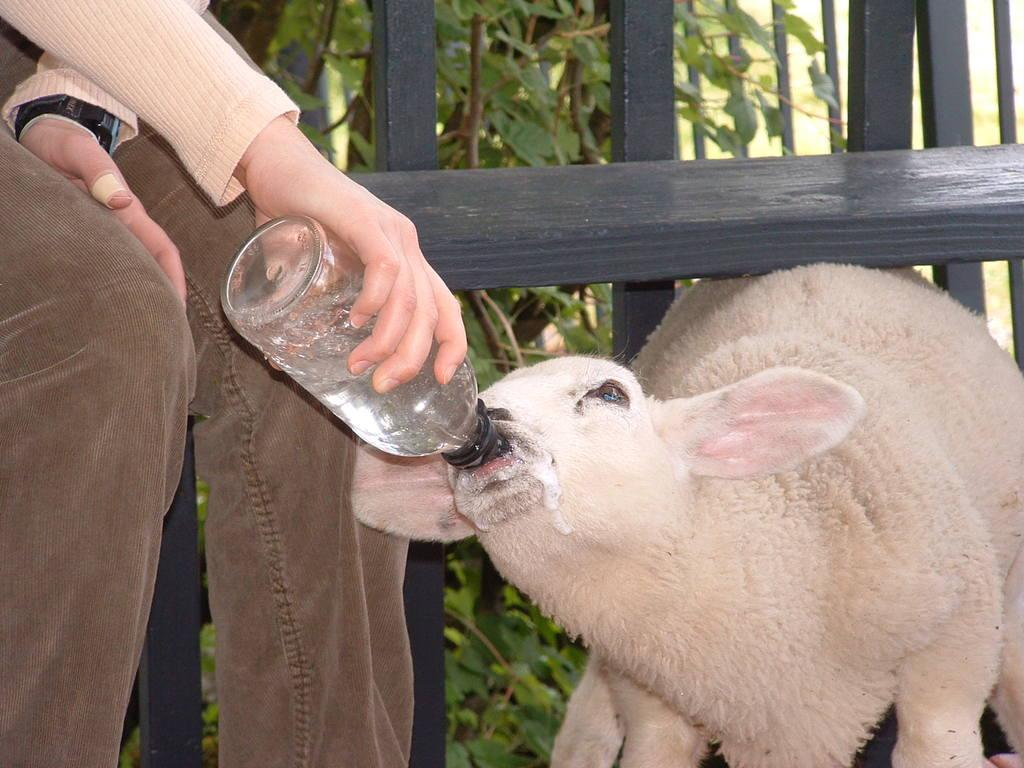What is the person doing in the image? The person is feeding an animal with a bottle. Can you describe the person's attire? The person is wearing a watch. What can be seen in the background of the image? There is wooden fencing and trees in the background. Where is the nest of the owl in the image? There is no owl or nest present in the image. What type of leaf can be seen falling from the tree in the image? There is no leaf falling from the tree in the image. 